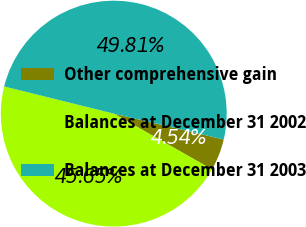Convert chart. <chart><loc_0><loc_0><loc_500><loc_500><pie_chart><fcel>Other comprehensive gain<fcel>Balances at December 31 2002<fcel>Balances at December 31 2003<nl><fcel>4.54%<fcel>45.65%<fcel>49.81%<nl></chart> 